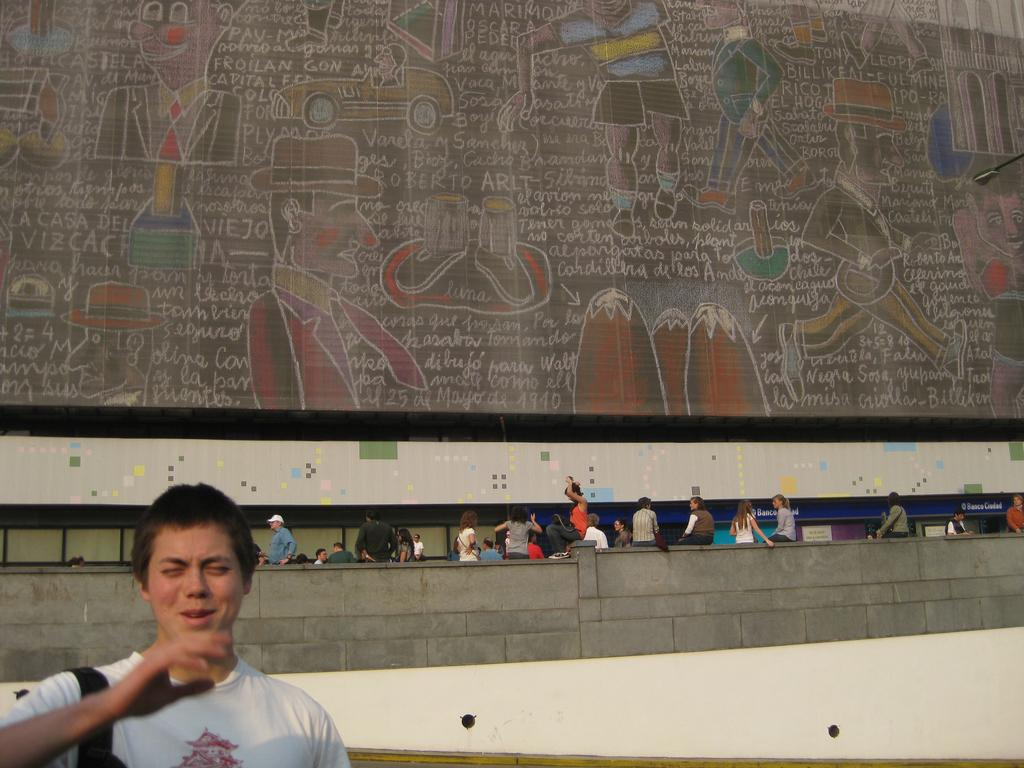What is the main subject of the image? The main subject of the image is a group of people. Can you describe the setting of the image? In the background of the image, there are people, vehicles, objects, and something written. How can you identify the person in the front of the image? The person in the front of the image is wearing a white top. What type of insect can be seen crawling on the development in the image? There is no development or insect present in the image. 